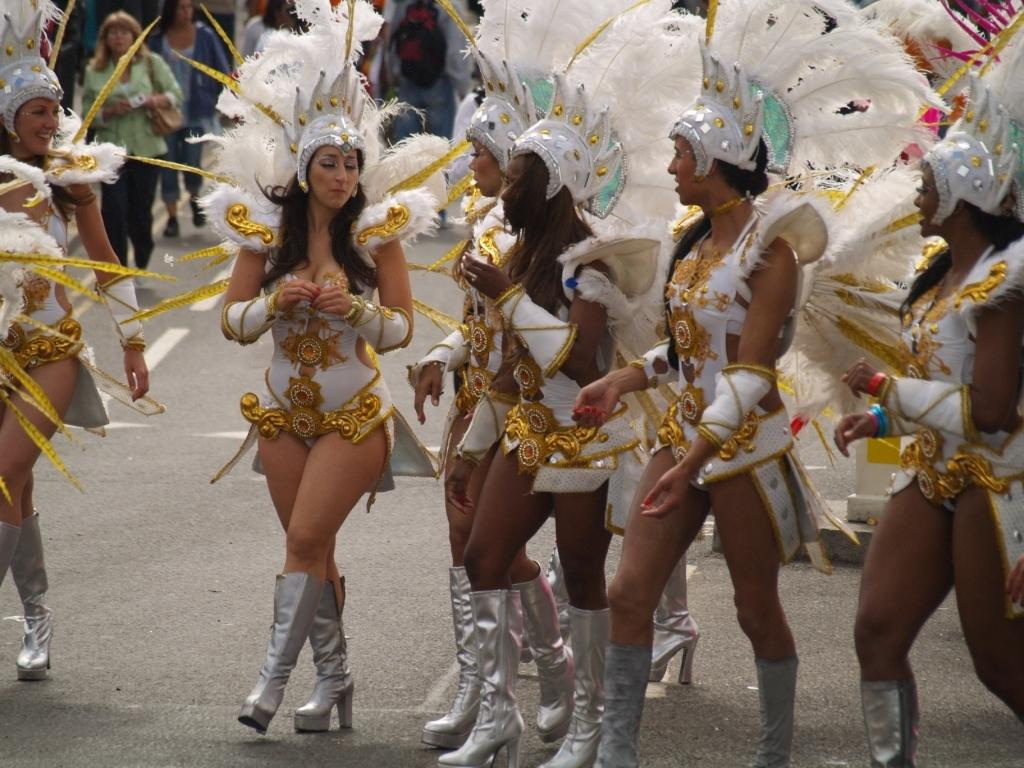What is the main subject of the image? The main subject of the image is a group of people. What are the people wearing in the image? The people are wearing fancy dresses in the image. What specific detail can be observed about the fancy dresses? The fancy dresses have feathers attached to them. What type of bell can be heard ringing in the image? There is no bell present in the image, and therefore no sound can be heard. 